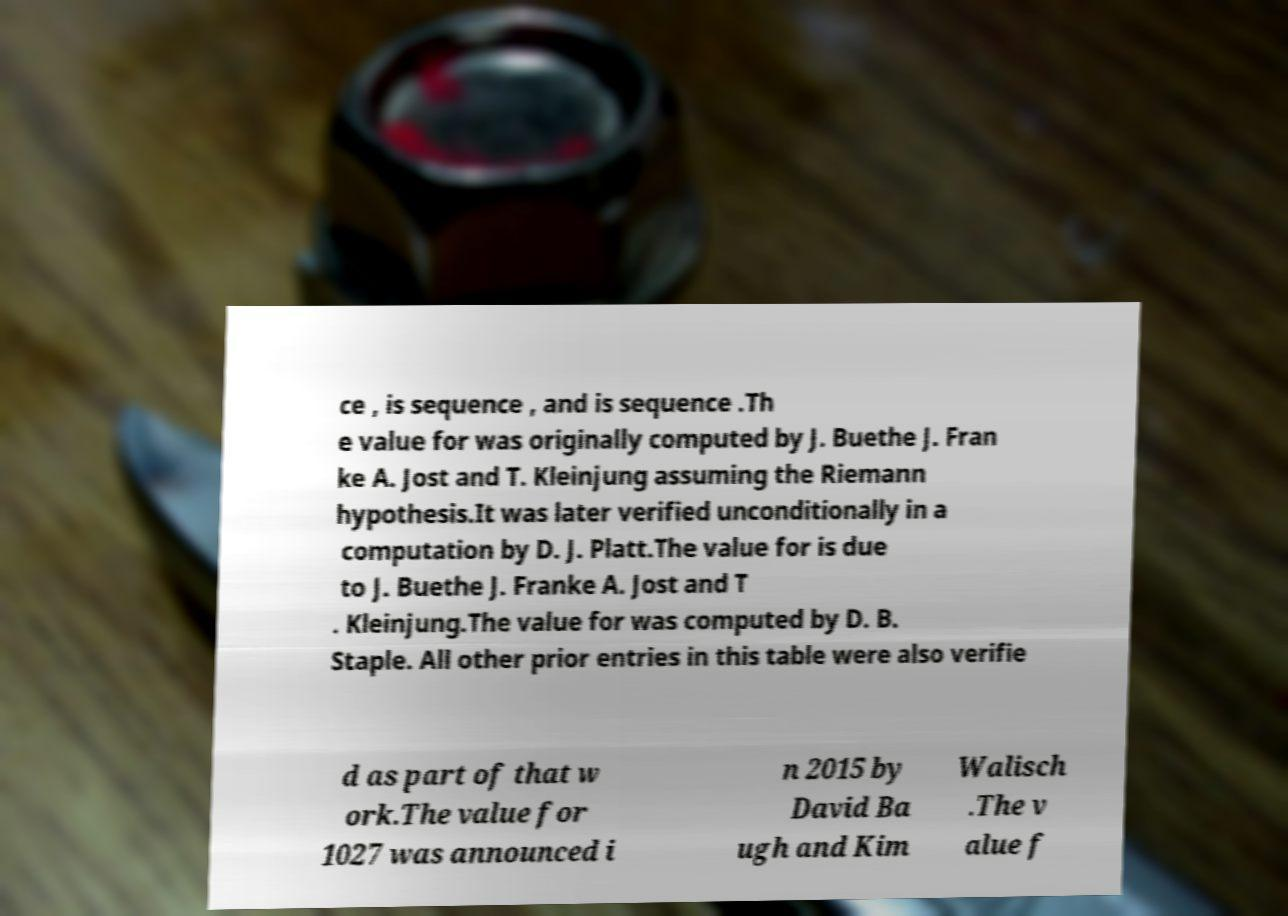There's text embedded in this image that I need extracted. Can you transcribe it verbatim? ce , is sequence , and is sequence .Th e value for was originally computed by J. Buethe J. Fran ke A. Jost and T. Kleinjung assuming the Riemann hypothesis.It was later verified unconditionally in a computation by D. J. Platt.The value for is due to J. Buethe J. Franke A. Jost and T . Kleinjung.The value for was computed by D. B. Staple. All other prior entries in this table were also verifie d as part of that w ork.The value for 1027 was announced i n 2015 by David Ba ugh and Kim Walisch .The v alue f 